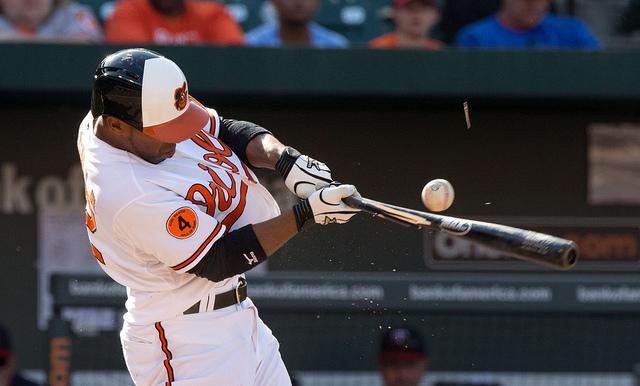What is the man hitting?
Keep it brief. Baseball. Did this mans bat break?
Concise answer only. Yes. Is this a soccer ball?
Write a very short answer. No. What team does he belong to?
Quick response, please. Orioles. Is the batter going to hit the ball?
Quick response, please. Yes. 